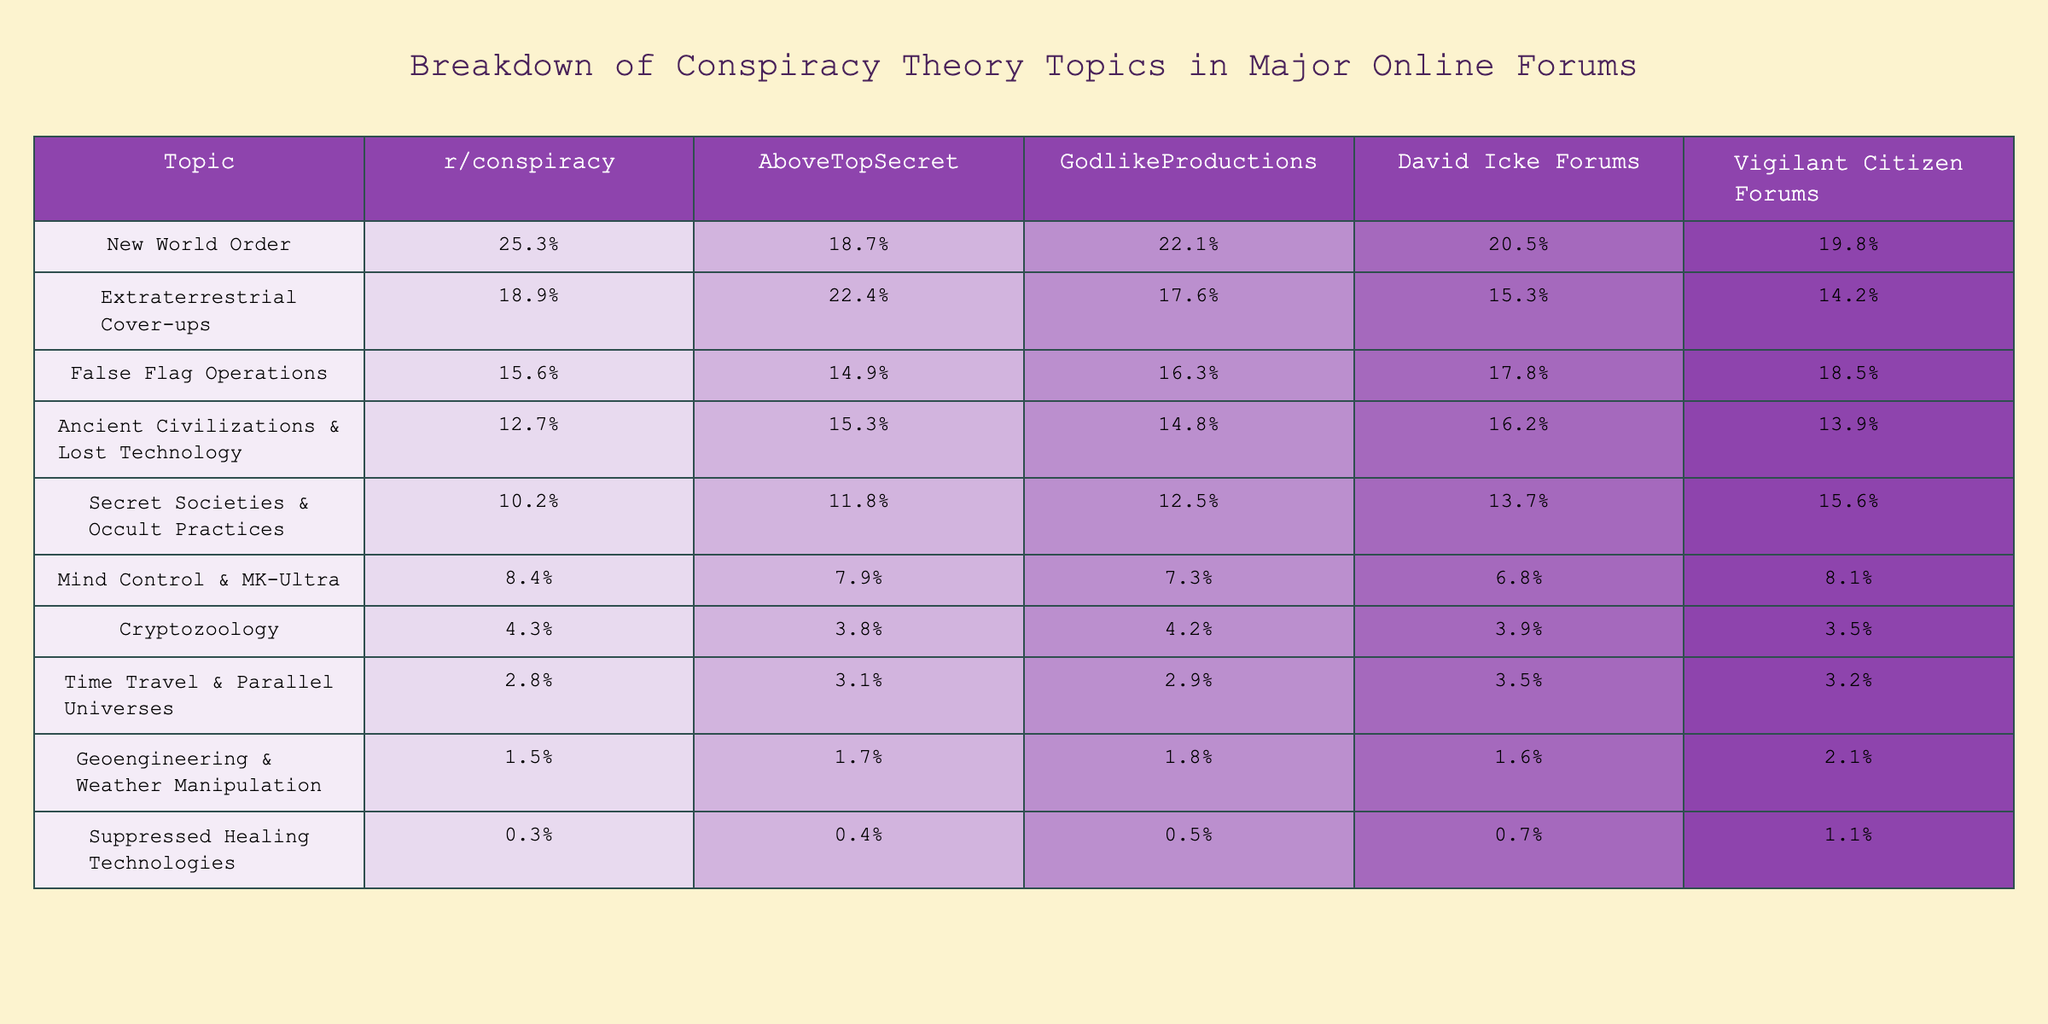What percentage of discussions is dedicated to the New World Order on r/conspiracy? The table shows that the percentage for the New World Order topic on r/conspiracy is 25.3%.
Answer: 25.3% Which forum has the highest percentage of discussions on Extraterrestrial Cover-ups? Among the forums listed, AboveTopSecret has the highest percentage at 22.4% for Extraterrestrial Cover-ups.
Answer: AboveTopSecret What is the difference in percentage between the highest and lowest topics discussed in the David Icke Forums? The highest topic is False Flag Operations at 17.8%, and the lowest is Suppressed Healing Technologies at 0.7%. The difference is 17.8% - 0.7% = 17.1%.
Answer: 17.1% What is the average percentage of discussions about Secret Societies & Occult Practices across all forums? The percentages for Secret Societies & Occult Practices are: r/conspiracy (10.2%), AboveTopSecret (11.8%), GodlikeProductions (12.5%), David Icke Forums (13.7%), and Vigilant Citizen Forums (15.6%). The average is (10.2 + 11.8 + 12.5 + 13.7 + 15.6) / 5 = 12.76%.
Answer: 12.76% Is the percentage of Mind Control & MK-Ultra discussions higher than that of Time Travel & Parallel Universes in any forum? In the table, Mind Control & MK-Ultra is 8.4% on r/conspiracy and 6.8% on David Icke Forums, while Time Travel & Parallel Universes is 2.8% on r/conspiracy and 3.5% on David Icke Forums. Mind Control & MK-Ultra is higher in all except for the David Icke Forums.
Answer: Yes Which conspiracy theory topic has the lowest percentage across all forums? The table indicates that Suppressed Healing Technologies has the lowest percentage across all forums at 0.3%, 0.4%, 0.5%, 0.7%, and 1.1%.
Answer: Suppressed Healing Technologies If we sum the percentages of Ancient Civilizations & Lost Technology and Geoengineering & Weather Manipulation on GodlikeProductions, what is the result? The percentages are 14.8% for Ancient Civilizations & Lost Technology and 1.8% for Geoengineering & Weather Manipulation on GodlikeProductions. The sum is 14.8% + 1.8% = 16.6%.
Answer: 16.6% Does the Vigilant Citizen Forums have a higher percentage of discussions on False Flag Operations than r/conspiracy? Vigilant Citizen Forums shows 18.5% for False Flag Operations, while r/conspiracy shows 15.6%. Since 18.5% is greater than 15.6%, the Vigilant Citizen Forums does have a higher percentage.
Answer: Yes What percentage of discussions relate to Cryptozoology on the AboveTopSecret forum? The percentage for Cryptozoology on AboveTopSecret is 3.8%.
Answer: 3.8% Which two topics combined have the closest percentages in the GodlikeProductions forum? The percentages for Ancient Civilizations & Lost Technology (14.8%) and False Flag Operations (16.3%) compared to the next closest topic, Secret Societies & Occult Practices (12.5%), suggest the closest pair are Ancient Civilizations & Lost Technology and False Flag Operations. Their combined percentage is 14.8% + 16.3% = 31.1%.
Answer: Ancient Civilizations & Lost Technology and False Flag Operations 